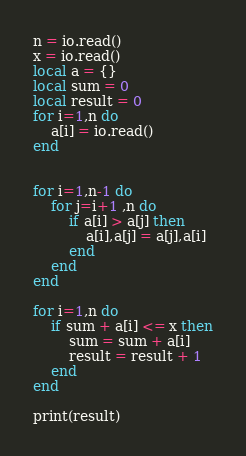Convert code to text. <code><loc_0><loc_0><loc_500><loc_500><_Lua_>n = io.read()
x = io.read()
local a = {}
local sum = 0
local result = 0
for i=1,n do
	a[i] = io.read()
end


for i=1,n-1 do
	for j=i+1 ,n do
		if a[i] > a[j] then
			a[i],a[j] = a[j],a[i]
		end
	end
end

for i=1,n do
	if sum + a[i] <= x then
		sum = sum + a[i]
		result = result + 1
	end
end

print(result)</code> 